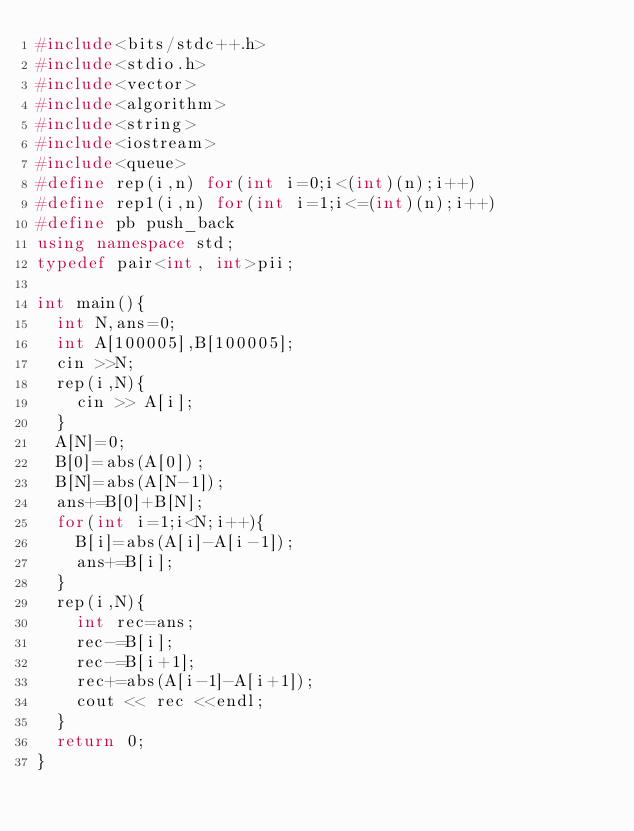<code> <loc_0><loc_0><loc_500><loc_500><_C++_>#include<bits/stdc++.h>
#include<stdio.h>
#include<vector>
#include<algorithm>
#include<string>
#include<iostream>
#include<queue>
#define rep(i,n) for(int i=0;i<(int)(n);i++)
#define rep1(i,n) for(int i=1;i<=(int)(n);i++)
#define pb push_back
using namespace std;
typedef pair<int, int>pii;

int main(){
	int N,ans=0;
	int A[100005],B[100005];
	cin >>N;
	rep(i,N){
		cin >> A[i];
	}
	A[N]=0;
	B[0]=abs(A[0]);
	B[N]=abs(A[N-1]);
	ans+=B[0]+B[N];
	for(int i=1;i<N;i++){
		B[i]=abs(A[i]-A[i-1]);
		ans+=B[i];
	}
	rep(i,N){
		int rec=ans;
		rec-=B[i];
		rec-=B[i+1];
		rec+=abs(A[i-1]-A[i+1]);
		cout << rec <<endl;
	}
	return 0;
}</code> 